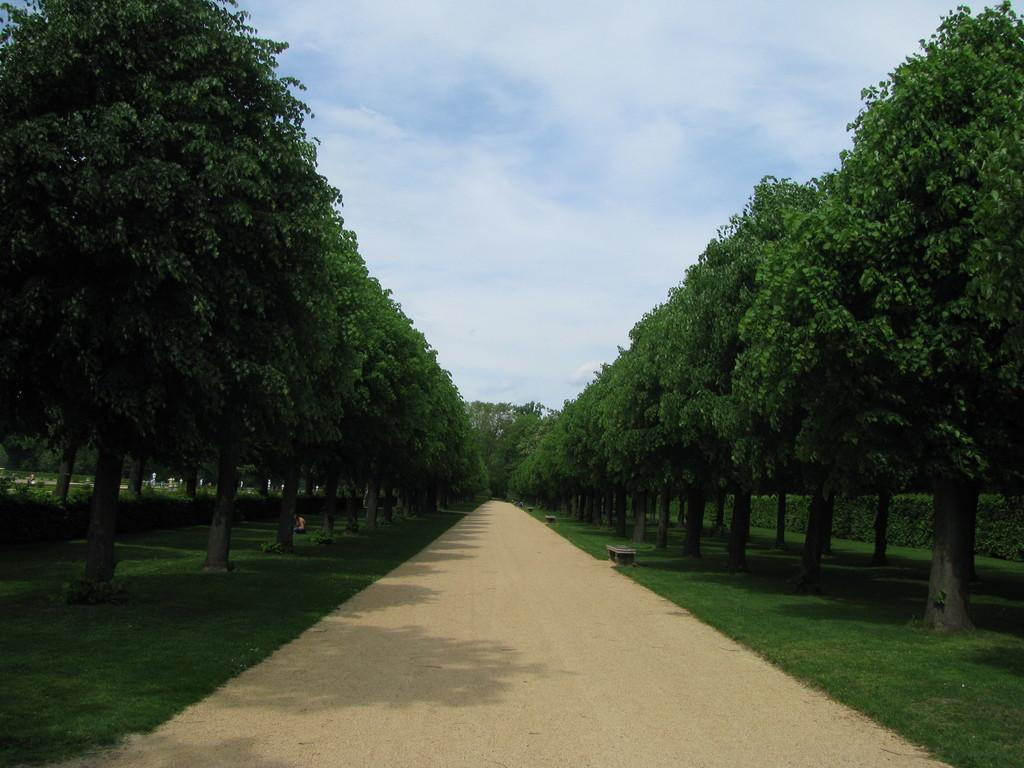What type of vegetation is present on both sides of the image? There are green trees on either side of the image. What can be seen at the top of the image? The sky is visible at the top of the image. How many toes can be seen on the trees in the image? Trees do not have toes, so this question is not applicable to the image. 